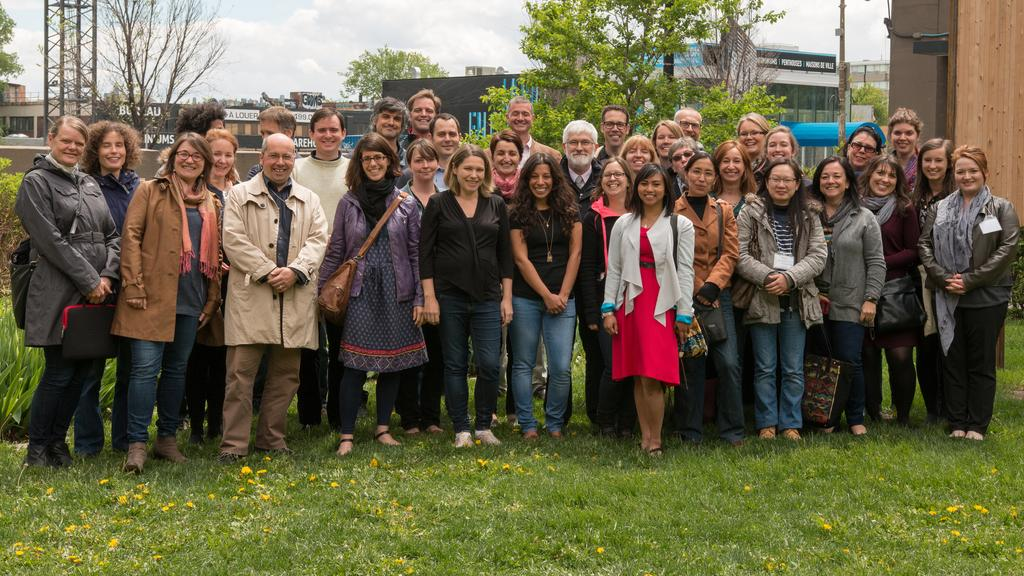How many people are in the image? There is a group of people in the image. What is the facial expression of the people in the image? The people are smiling. What can be seen in the background of the image? There are poles, metal structures, trees, and buildings in the background of the image. How does the boy's performance in the competition affect the people in the image? There is no boy or competition present in the image, so it is not possible to determine any effect on the people in the image. 